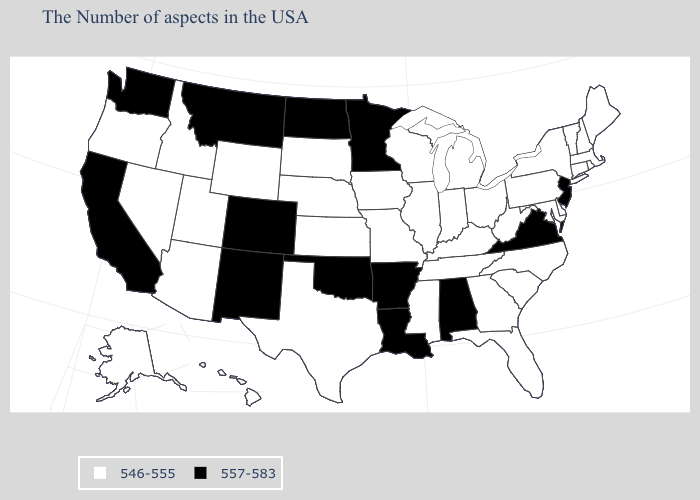Among the states that border Vermont , which have the lowest value?
Short answer required. Massachusetts, New Hampshire, New York. Name the states that have a value in the range 546-555?
Give a very brief answer. Maine, Massachusetts, Rhode Island, New Hampshire, Vermont, Connecticut, New York, Delaware, Maryland, Pennsylvania, North Carolina, South Carolina, West Virginia, Ohio, Florida, Georgia, Michigan, Kentucky, Indiana, Tennessee, Wisconsin, Illinois, Mississippi, Missouri, Iowa, Kansas, Nebraska, Texas, South Dakota, Wyoming, Utah, Arizona, Idaho, Nevada, Oregon, Alaska, Hawaii. How many symbols are there in the legend?
Short answer required. 2. Which states have the highest value in the USA?
Quick response, please. New Jersey, Virginia, Alabama, Louisiana, Arkansas, Minnesota, Oklahoma, North Dakota, Colorado, New Mexico, Montana, California, Washington. What is the value of West Virginia?
Concise answer only. 546-555. What is the value of Hawaii?
Keep it brief. 546-555. Which states have the lowest value in the USA?
Be succinct. Maine, Massachusetts, Rhode Island, New Hampshire, Vermont, Connecticut, New York, Delaware, Maryland, Pennsylvania, North Carolina, South Carolina, West Virginia, Ohio, Florida, Georgia, Michigan, Kentucky, Indiana, Tennessee, Wisconsin, Illinois, Mississippi, Missouri, Iowa, Kansas, Nebraska, Texas, South Dakota, Wyoming, Utah, Arizona, Idaho, Nevada, Oregon, Alaska, Hawaii. What is the value of New Hampshire?
Quick response, please. 546-555. Name the states that have a value in the range 546-555?
Give a very brief answer. Maine, Massachusetts, Rhode Island, New Hampshire, Vermont, Connecticut, New York, Delaware, Maryland, Pennsylvania, North Carolina, South Carolina, West Virginia, Ohio, Florida, Georgia, Michigan, Kentucky, Indiana, Tennessee, Wisconsin, Illinois, Mississippi, Missouri, Iowa, Kansas, Nebraska, Texas, South Dakota, Wyoming, Utah, Arizona, Idaho, Nevada, Oregon, Alaska, Hawaii. Name the states that have a value in the range 546-555?
Concise answer only. Maine, Massachusetts, Rhode Island, New Hampshire, Vermont, Connecticut, New York, Delaware, Maryland, Pennsylvania, North Carolina, South Carolina, West Virginia, Ohio, Florida, Georgia, Michigan, Kentucky, Indiana, Tennessee, Wisconsin, Illinois, Mississippi, Missouri, Iowa, Kansas, Nebraska, Texas, South Dakota, Wyoming, Utah, Arizona, Idaho, Nevada, Oregon, Alaska, Hawaii. Name the states that have a value in the range 557-583?
Be succinct. New Jersey, Virginia, Alabama, Louisiana, Arkansas, Minnesota, Oklahoma, North Dakota, Colorado, New Mexico, Montana, California, Washington. Which states hav the highest value in the South?
Keep it brief. Virginia, Alabama, Louisiana, Arkansas, Oklahoma. Name the states that have a value in the range 546-555?
Quick response, please. Maine, Massachusetts, Rhode Island, New Hampshire, Vermont, Connecticut, New York, Delaware, Maryland, Pennsylvania, North Carolina, South Carolina, West Virginia, Ohio, Florida, Georgia, Michigan, Kentucky, Indiana, Tennessee, Wisconsin, Illinois, Mississippi, Missouri, Iowa, Kansas, Nebraska, Texas, South Dakota, Wyoming, Utah, Arizona, Idaho, Nevada, Oregon, Alaska, Hawaii. How many symbols are there in the legend?
Keep it brief. 2. 